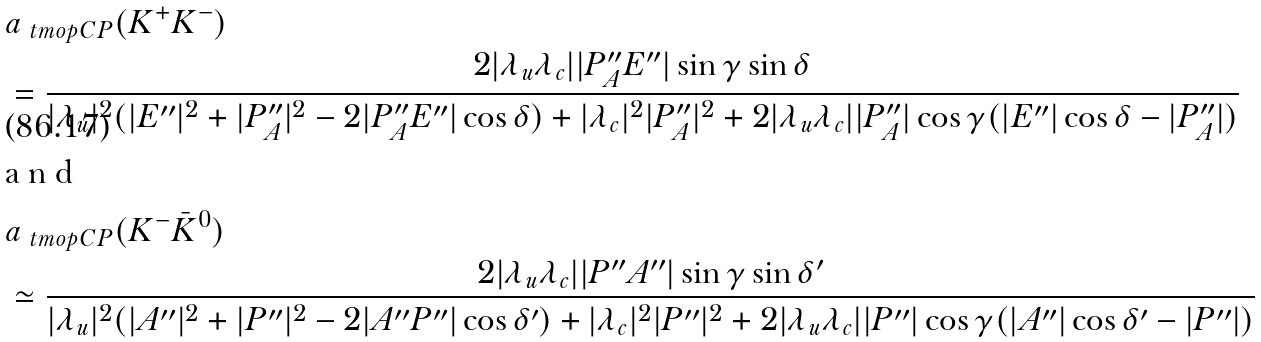Convert formula to latex. <formula><loc_0><loc_0><loc_500><loc_500>& a _ { \ t m o p { C P } } ( K ^ { + } K ^ { - } ) \\ & = \frac { 2 | \lambda _ { u } \lambda _ { c } | | P ^ { \prime \prime } _ { A } E ^ { \prime \prime } | \sin \gamma \sin \delta } { | \lambda _ { u } | ^ { 2 } ( | E ^ { \prime \prime } | ^ { 2 } + | P ^ { \prime \prime } _ { A } | ^ { 2 } - 2 | P ^ { \prime \prime } _ { A } E ^ { \prime \prime } | \cos \delta ) + | \lambda _ { c } | ^ { 2 } | P ^ { \prime \prime } _ { A } | ^ { 2 } + 2 | \lambda _ { u } \lambda _ { c } | | P ^ { \prime \prime } _ { A } | \cos \gamma ( | E ^ { \prime \prime } | \cos \delta - | P ^ { \prime \prime } _ { A } | ) } \intertext { a n d } & a _ { \ t m o p { C P } } ( K ^ { - } \bar { K } ^ { 0 } ) \\ & \simeq \frac { 2 | \lambda _ { u } \lambda _ { c } | | P ^ { \prime \prime } A ^ { \prime \prime } | \sin \gamma \sin \delta ^ { \prime } } { | \lambda _ { u } | ^ { 2 } ( | A ^ { \prime \prime } | ^ { 2 } + | P ^ { \prime \prime } | ^ { 2 } - 2 | A ^ { \prime \prime } P ^ { \prime \prime } | \cos \delta ^ { \prime } ) + | \lambda _ { c } | ^ { 2 } | P ^ { \prime \prime } | ^ { 2 } + 2 | \lambda _ { u } \lambda _ { c } | | P ^ { \prime \prime } | \cos \gamma ( | A ^ { \prime \prime } | \cos \delta ^ { \prime } - | P ^ { \prime \prime } | ) }</formula> 